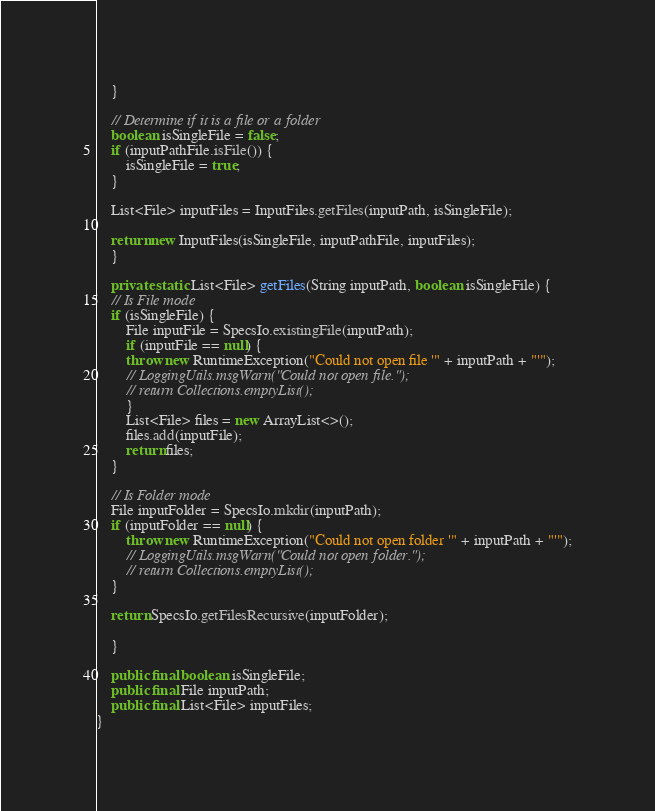Convert code to text. <code><loc_0><loc_0><loc_500><loc_500><_Java_>	}

	// Determine if it is a file or a folder
	boolean isSingleFile = false;
	if (inputPathFile.isFile()) {
	    isSingleFile = true;
	}

	List<File> inputFiles = InputFiles.getFiles(inputPath, isSingleFile);

	return new InputFiles(isSingleFile, inputPathFile, inputFiles);
    }

    private static List<File> getFiles(String inputPath, boolean isSingleFile) {
	// Is File mode
	if (isSingleFile) {
	    File inputFile = SpecsIo.existingFile(inputPath);
	    if (inputFile == null) {
		throw new RuntimeException("Could not open file '" + inputPath + "'");
		// LoggingUtils.msgWarn("Could not open file.");
		// return Collections.emptyList();
	    }
	    List<File> files = new ArrayList<>();
	    files.add(inputFile);
	    return files;
	}

	// Is Folder mode
	File inputFolder = SpecsIo.mkdir(inputPath);
	if (inputFolder == null) {
	    throw new RuntimeException("Could not open folder '" + inputPath + "'");
	    // LoggingUtils.msgWarn("Could not open folder.");
	    // return Collections.emptyList();
	}

	return SpecsIo.getFilesRecursive(inputFolder);

    }

    public final boolean isSingleFile;
    public final File inputPath;
    public final List<File> inputFiles;
}
</code> 